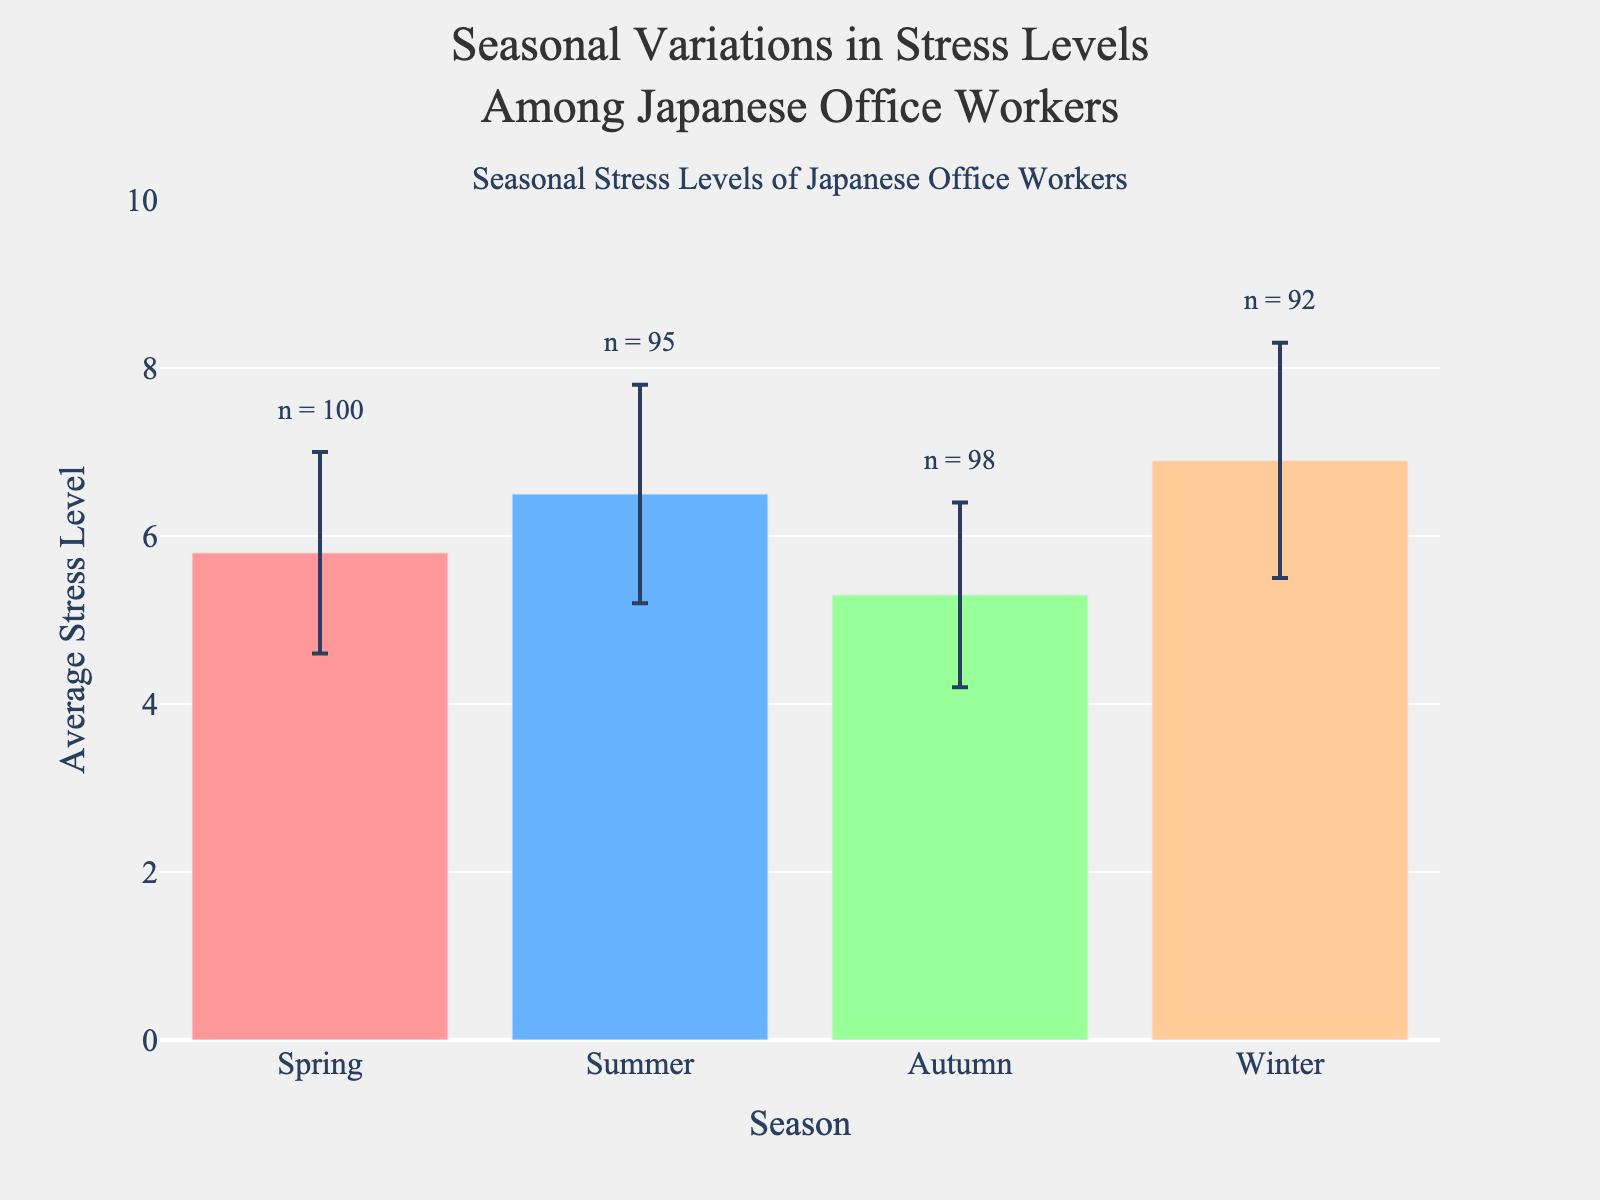What is the title of the figure? The title of the figure is usually located at the top, clearly stating the main topic of the plot. Here, it reads "Seasonal Variations in Stress Levels Among Japanese Office Workers".
Answer: Seasonal Variations in Stress Levels Among Japanese Office Workers What is the average stress level in Summer? To find this, look at the bar corresponding to Summer. The label on the y-axis indicates the average stress level.
Answer: 6.5 Which season has the highest average stress level? Compare the height of the bars across all seasons. The highest bar represents the highest average stress level.
Answer: Winter What is the standard deviation of stress levels for Spring? The standard deviation is represented by the error bars extending from the top of each bar. Refer to the error bar for the Spring season.
Answer: 1.2 How many sample sizes were there in Autumn? Look at the annotation above the Autumn bar, which contains the sample size information.
Answer: 98 What is the difference in average stress level between Winter and Autumn? Subtract the average stress level of Autumn from that of Winter (6.9 - 5.3).
Answer: 1.6 How does the average stress level in Spring compare to Summer? Observe the bar heights for both Spring and Summer. Spring has a lower bar than Summer.
Answer: lower Which season has the lowest average stress level? Compare the heights of the bars for all the seasons. The shortest bar represents the lowest average stress level.
Answer: Autumn What is the sum of the average stress levels across all seasons? Add the average stress levels for Spring, Summer, Autumn, and Winter (5.8 + 6.5 + 5.3 + 6.9).
Answer: 24.5 What is the range of stress levels depicted on the y-axis? Look at the y-axis starting and ending point values. The y-axis ranges from 0 to 10.
Answer: 0 to 10 